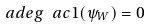<formula> <loc_0><loc_0><loc_500><loc_500>\ a d e g \ a c 1 ( \psi _ { W } ) = 0</formula> 